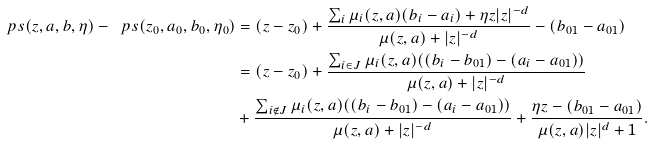Convert formula to latex. <formula><loc_0><loc_0><loc_500><loc_500>\ p s ( z , a , b , \eta ) - \ p s ( z _ { 0 } , a _ { 0 } , b _ { 0 } , \eta _ { 0 } ) & = ( z - z _ { 0 } ) + \frac { \sum _ { i } \mu _ { i } ( z , a ) ( b _ { i } - a _ { i } ) + \eta z | z | ^ { - d } } { \mu ( z , a ) + | z | ^ { - d } } - ( b _ { 0 1 } - a _ { 0 1 } ) \\ & = ( z - z _ { 0 } ) + \frac { \sum _ { i \in J } \mu _ { i } ( z , a ) ( ( b _ { i } - b _ { 0 1 } ) - ( a _ { i } - a _ { 0 1 } ) ) } { \mu ( z , a ) + | z | ^ { - d } } \\ & + \frac { \sum _ { i \notin J } \mu _ { i } ( z , a ) ( ( b _ { i } - b _ { 0 1 } ) - ( a _ { i } - a _ { 0 1 } ) ) } { \mu ( z , a ) + | z | ^ { - d } } + \frac { \eta z - ( b _ { 0 1 } - a _ { 0 1 } ) } { \mu ( z , a ) | z | ^ { d } + 1 } .</formula> 